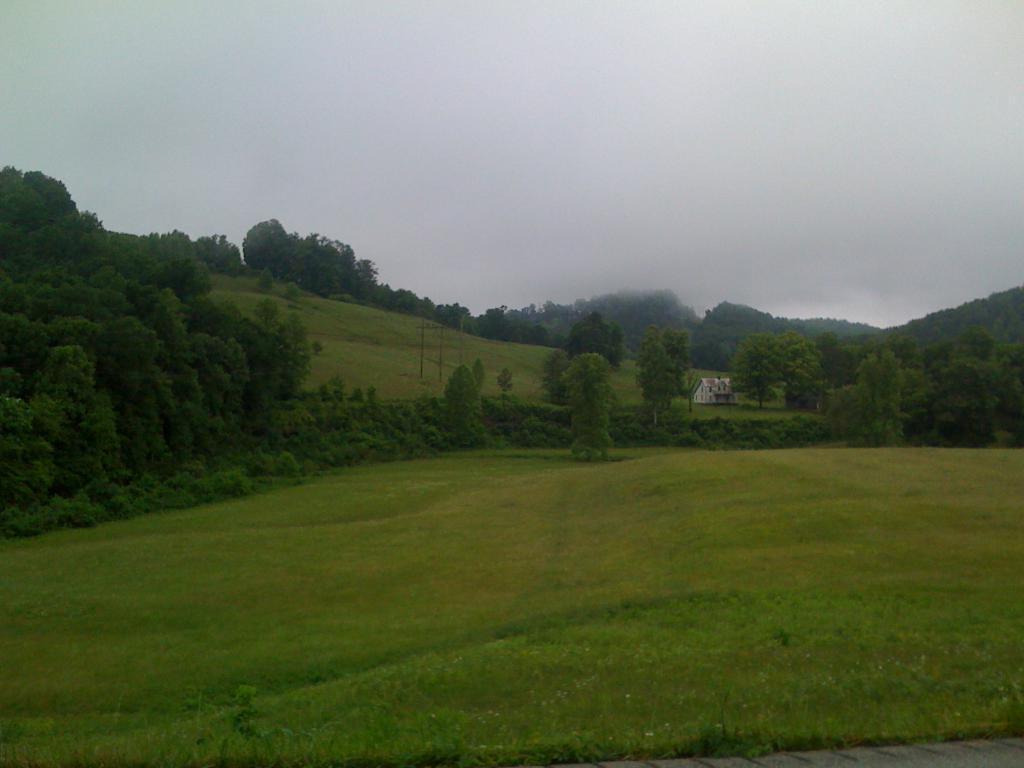Please provide a concise description of this image. In this image I can see the ground, some grass, few plants and few trees. In the background I can see a building, few trees and the sky. 